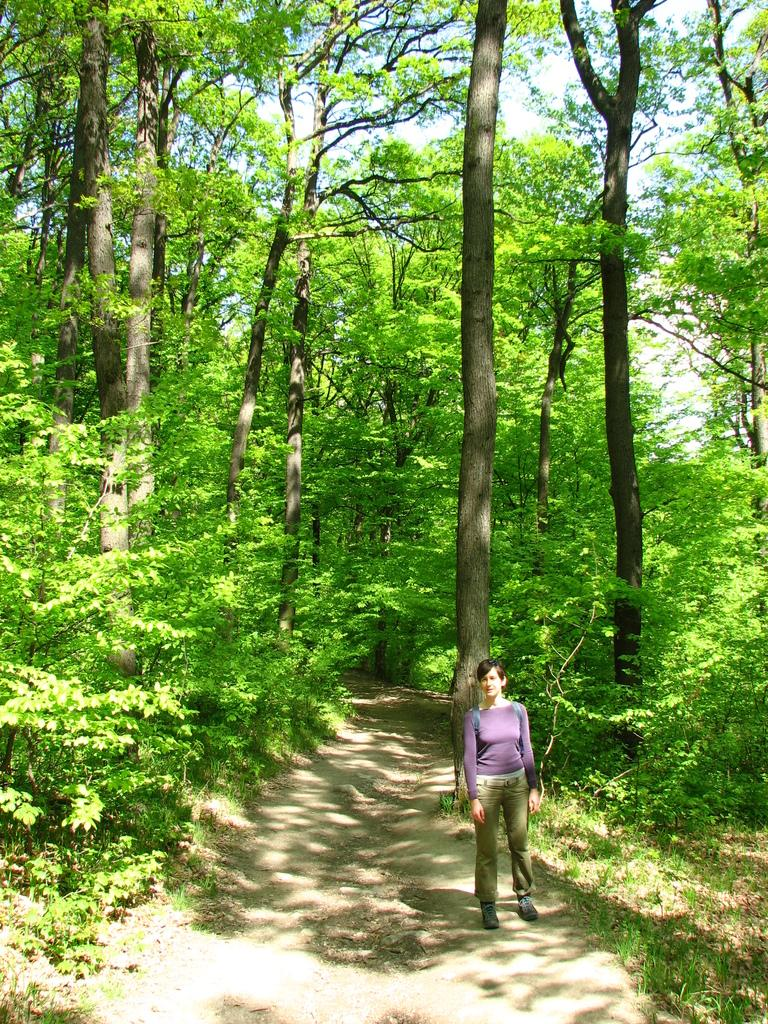Who is the main subject in the foreground of the image? There is a woman in the foreground of the image. What is the woman carrying on her back? The woman is wearing a backpack. Where is the woman standing in the image? The woman is standing on a path. What can be seen on either side of the path? There are trees on either side of the path. What is visible in the background of the image? The sky is visible in the background of the image. What type of quiver is the woman using to store her arrows in the image? There is no quiver or arrows present in the image; the woman is wearing a backpack. Is the woman driving a vehicle in the image? No, the woman is standing on a path, and there is no vehicle visible in the image. 